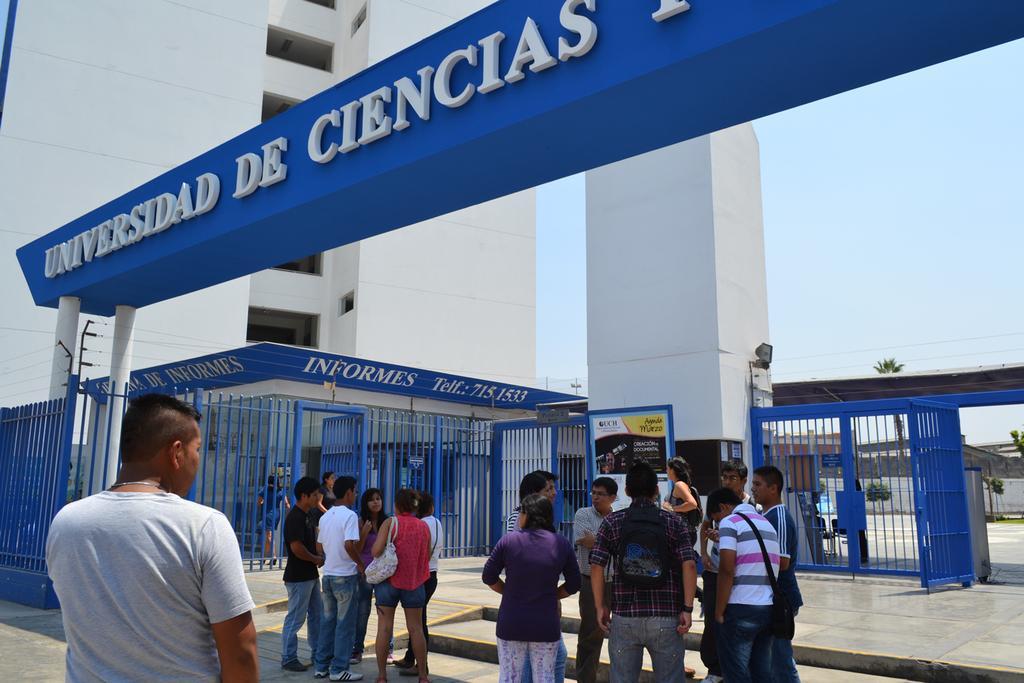Could you give a brief overview of what you see in this image? In this image there are group of persons standing. In the background there is a banner with some text written on it and there are fence which is blue in colour and there is a building which is white in colour. 